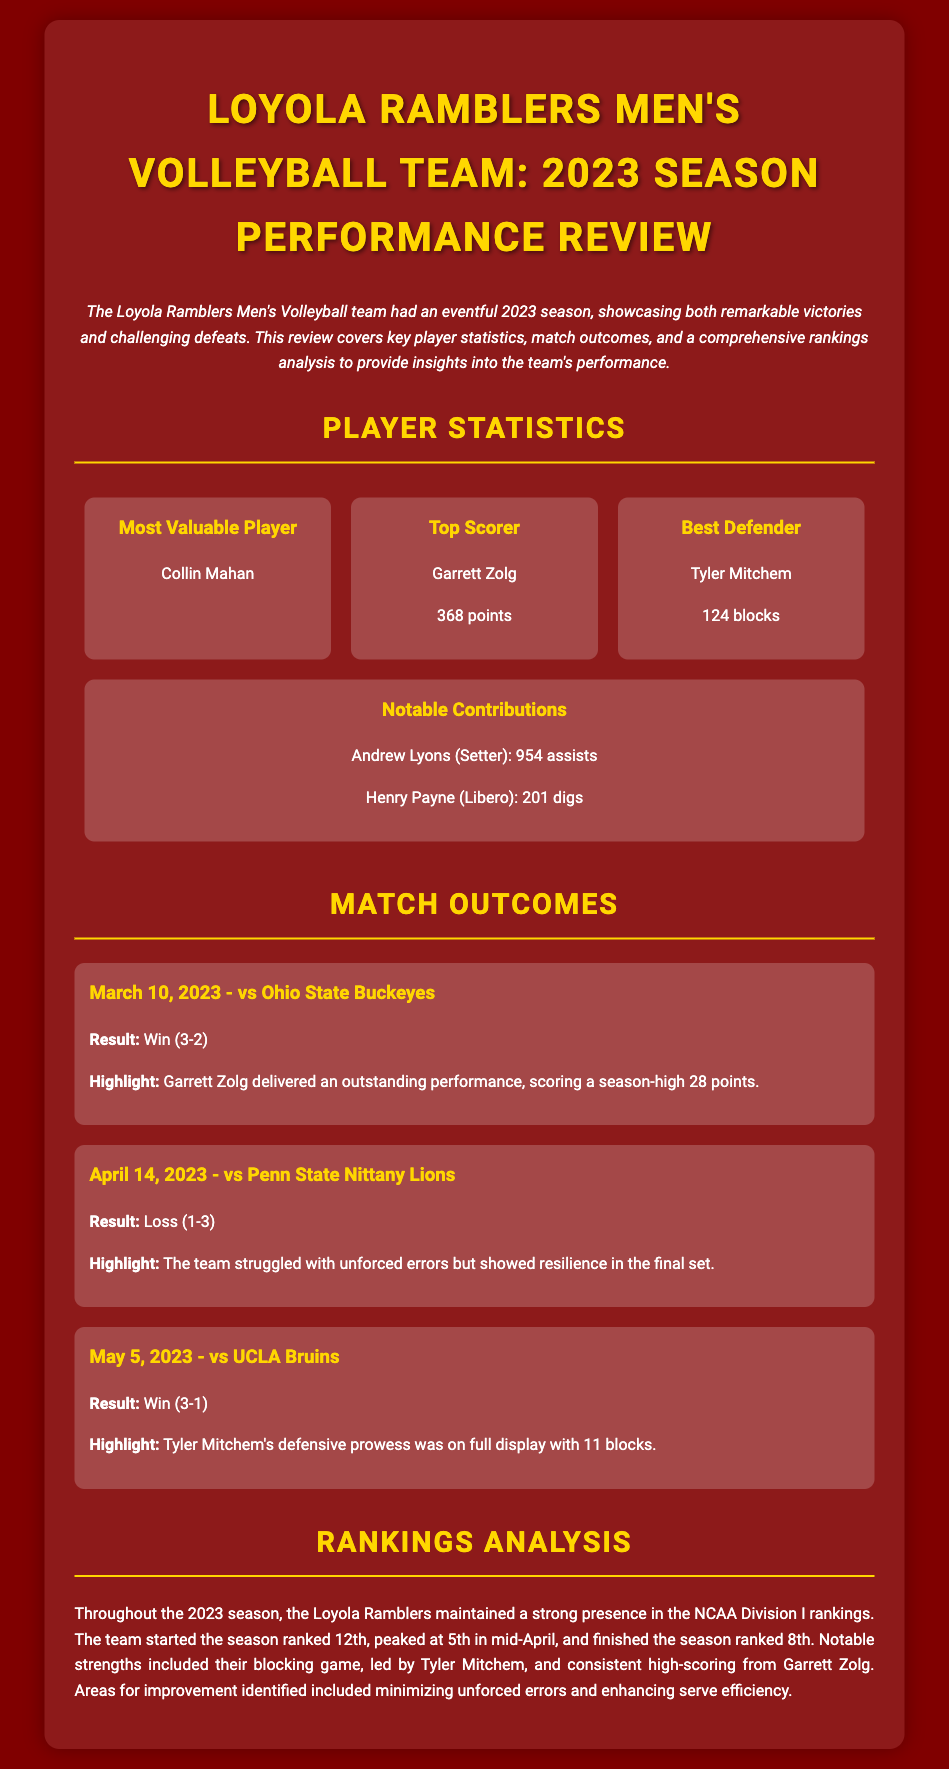What is the name of the Most Valuable Player? The document lists the Most Valuable Player as Collin Mahan.
Answer: Collin Mahan How many points did the Top Scorer achieve? The Top Scorer, Garrett Zolg, scored 368 points according to the document.
Answer: 368 points What was the outcome of the March 10 match against Ohio State? The match on March 10, 2023, against Ohio State resulted in a win with a score of 3-2.
Answer: Win (3-2) How many blocks did Tyler Mitchem achieve during the season? Tyler Mitchem achieved 124 blocks, as stated in the player statistics section.
Answer: 124 blocks At what ranking did the Loyola Ramblers finish the season? The document indicates that the team finished the season ranked 8th in the NCAA Division I rankings.
Answer: 8th What significant highlight occurred during the match against UCLA? During the match against UCLA, Tyler Mitchem made a highlight by achieving 11 blocks.
Answer: 11 blocks Who was the Setter for the team and how many assists did they have? The Setter mentioned in the document is Andrew Lyons, who made 954 assists.
Answer: 954 assists What was the team's starting ranking at the beginning of the season? The starting ranking for the Loyola Ramblers at the season's beginning was 12th.
Answer: 12th What area for improvement was identified in the rankings analysis? The document points out that minimizing unforced errors was an area for improvement for the team.
Answer: Minimizing unforced errors 